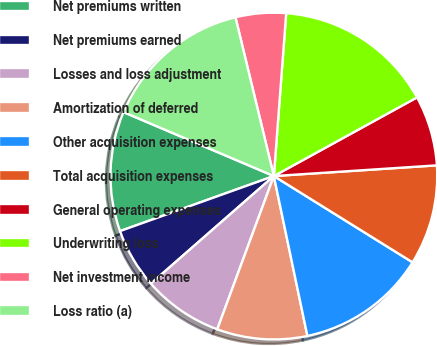Convert chart. <chart><loc_0><loc_0><loc_500><loc_500><pie_chart><fcel>Net premiums written<fcel>Net premiums earned<fcel>Losses and loss adjustment<fcel>Amortization of deferred<fcel>Other acquisition expenses<fcel>Total acquisition expenses<fcel>General operating expenses<fcel>Underwriting loss<fcel>Net investment income<fcel>Loss ratio (a)<nl><fcel>11.87%<fcel>5.97%<fcel>7.93%<fcel>8.92%<fcel>12.85%<fcel>9.9%<fcel>6.95%<fcel>15.8%<fcel>4.98%<fcel>14.82%<nl></chart> 